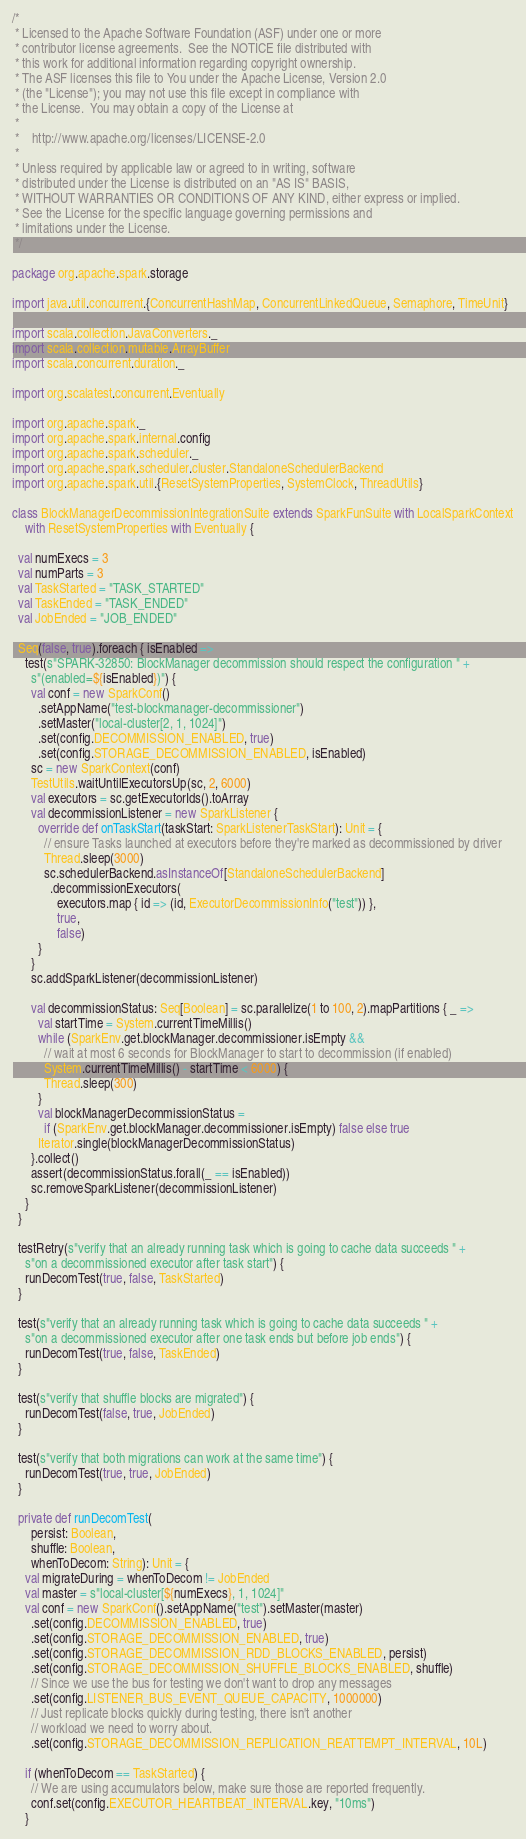Convert code to text. <code><loc_0><loc_0><loc_500><loc_500><_Scala_>/*
 * Licensed to the Apache Software Foundation (ASF) under one or more
 * contributor license agreements.  See the NOTICE file distributed with
 * this work for additional information regarding copyright ownership.
 * The ASF licenses this file to You under the Apache License, Version 2.0
 * (the "License"); you may not use this file except in compliance with
 * the License.  You may obtain a copy of the License at
 *
 *    http://www.apache.org/licenses/LICENSE-2.0
 *
 * Unless required by applicable law or agreed to in writing, software
 * distributed under the License is distributed on an "AS IS" BASIS,
 * WITHOUT WARRANTIES OR CONDITIONS OF ANY KIND, either express or implied.
 * See the License for the specific language governing permissions and
 * limitations under the License.
 */

package org.apache.spark.storage

import java.util.concurrent.{ConcurrentHashMap, ConcurrentLinkedQueue, Semaphore, TimeUnit}

import scala.collection.JavaConverters._
import scala.collection.mutable.ArrayBuffer
import scala.concurrent.duration._

import org.scalatest.concurrent.Eventually

import org.apache.spark._
import org.apache.spark.internal.config
import org.apache.spark.scheduler._
import org.apache.spark.scheduler.cluster.StandaloneSchedulerBackend
import org.apache.spark.util.{ResetSystemProperties, SystemClock, ThreadUtils}

class BlockManagerDecommissionIntegrationSuite extends SparkFunSuite with LocalSparkContext
    with ResetSystemProperties with Eventually {

  val numExecs = 3
  val numParts = 3
  val TaskStarted = "TASK_STARTED"
  val TaskEnded = "TASK_ENDED"
  val JobEnded = "JOB_ENDED"

  Seq(false, true).foreach { isEnabled =>
    test(s"SPARK-32850: BlockManager decommission should respect the configuration " +
      s"(enabled=${isEnabled})") {
      val conf = new SparkConf()
        .setAppName("test-blockmanager-decommissioner")
        .setMaster("local-cluster[2, 1, 1024]")
        .set(config.DECOMMISSION_ENABLED, true)
        .set(config.STORAGE_DECOMMISSION_ENABLED, isEnabled)
      sc = new SparkContext(conf)
      TestUtils.waitUntilExecutorsUp(sc, 2, 6000)
      val executors = sc.getExecutorIds().toArray
      val decommissionListener = new SparkListener {
        override def onTaskStart(taskStart: SparkListenerTaskStart): Unit = {
          // ensure Tasks launched at executors before they're marked as decommissioned by driver
          Thread.sleep(3000)
          sc.schedulerBackend.asInstanceOf[StandaloneSchedulerBackend]
            .decommissionExecutors(
              executors.map { id => (id, ExecutorDecommissionInfo("test")) },
              true,
              false)
        }
      }
      sc.addSparkListener(decommissionListener)

      val decommissionStatus: Seq[Boolean] = sc.parallelize(1 to 100, 2).mapPartitions { _ =>
        val startTime = System.currentTimeMillis()
        while (SparkEnv.get.blockManager.decommissioner.isEmpty &&
          // wait at most 6 seconds for BlockManager to start to decommission (if enabled)
          System.currentTimeMillis() - startTime < 6000) {
          Thread.sleep(300)
        }
        val blockManagerDecommissionStatus =
          if (SparkEnv.get.blockManager.decommissioner.isEmpty) false else true
        Iterator.single(blockManagerDecommissionStatus)
      }.collect()
      assert(decommissionStatus.forall(_ == isEnabled))
      sc.removeSparkListener(decommissionListener)
    }
  }

  testRetry(s"verify that an already running task which is going to cache data succeeds " +
    s"on a decommissioned executor after task start") {
    runDecomTest(true, false, TaskStarted)
  }

  test(s"verify that an already running task which is going to cache data succeeds " +
    s"on a decommissioned executor after one task ends but before job ends") {
    runDecomTest(true, false, TaskEnded)
  }

  test(s"verify that shuffle blocks are migrated") {
    runDecomTest(false, true, JobEnded)
  }

  test(s"verify that both migrations can work at the same time") {
    runDecomTest(true, true, JobEnded)
  }

  private def runDecomTest(
      persist: Boolean,
      shuffle: Boolean,
      whenToDecom: String): Unit = {
    val migrateDuring = whenToDecom != JobEnded
    val master = s"local-cluster[${numExecs}, 1, 1024]"
    val conf = new SparkConf().setAppName("test").setMaster(master)
      .set(config.DECOMMISSION_ENABLED, true)
      .set(config.STORAGE_DECOMMISSION_ENABLED, true)
      .set(config.STORAGE_DECOMMISSION_RDD_BLOCKS_ENABLED, persist)
      .set(config.STORAGE_DECOMMISSION_SHUFFLE_BLOCKS_ENABLED, shuffle)
      // Since we use the bus for testing we don't want to drop any messages
      .set(config.LISTENER_BUS_EVENT_QUEUE_CAPACITY, 1000000)
      // Just replicate blocks quickly during testing, there isn't another
      // workload we need to worry about.
      .set(config.STORAGE_DECOMMISSION_REPLICATION_REATTEMPT_INTERVAL, 10L)

    if (whenToDecom == TaskStarted) {
      // We are using accumulators below, make sure those are reported frequently.
      conf.set(config.EXECUTOR_HEARTBEAT_INTERVAL.key, "10ms")
    }</code> 